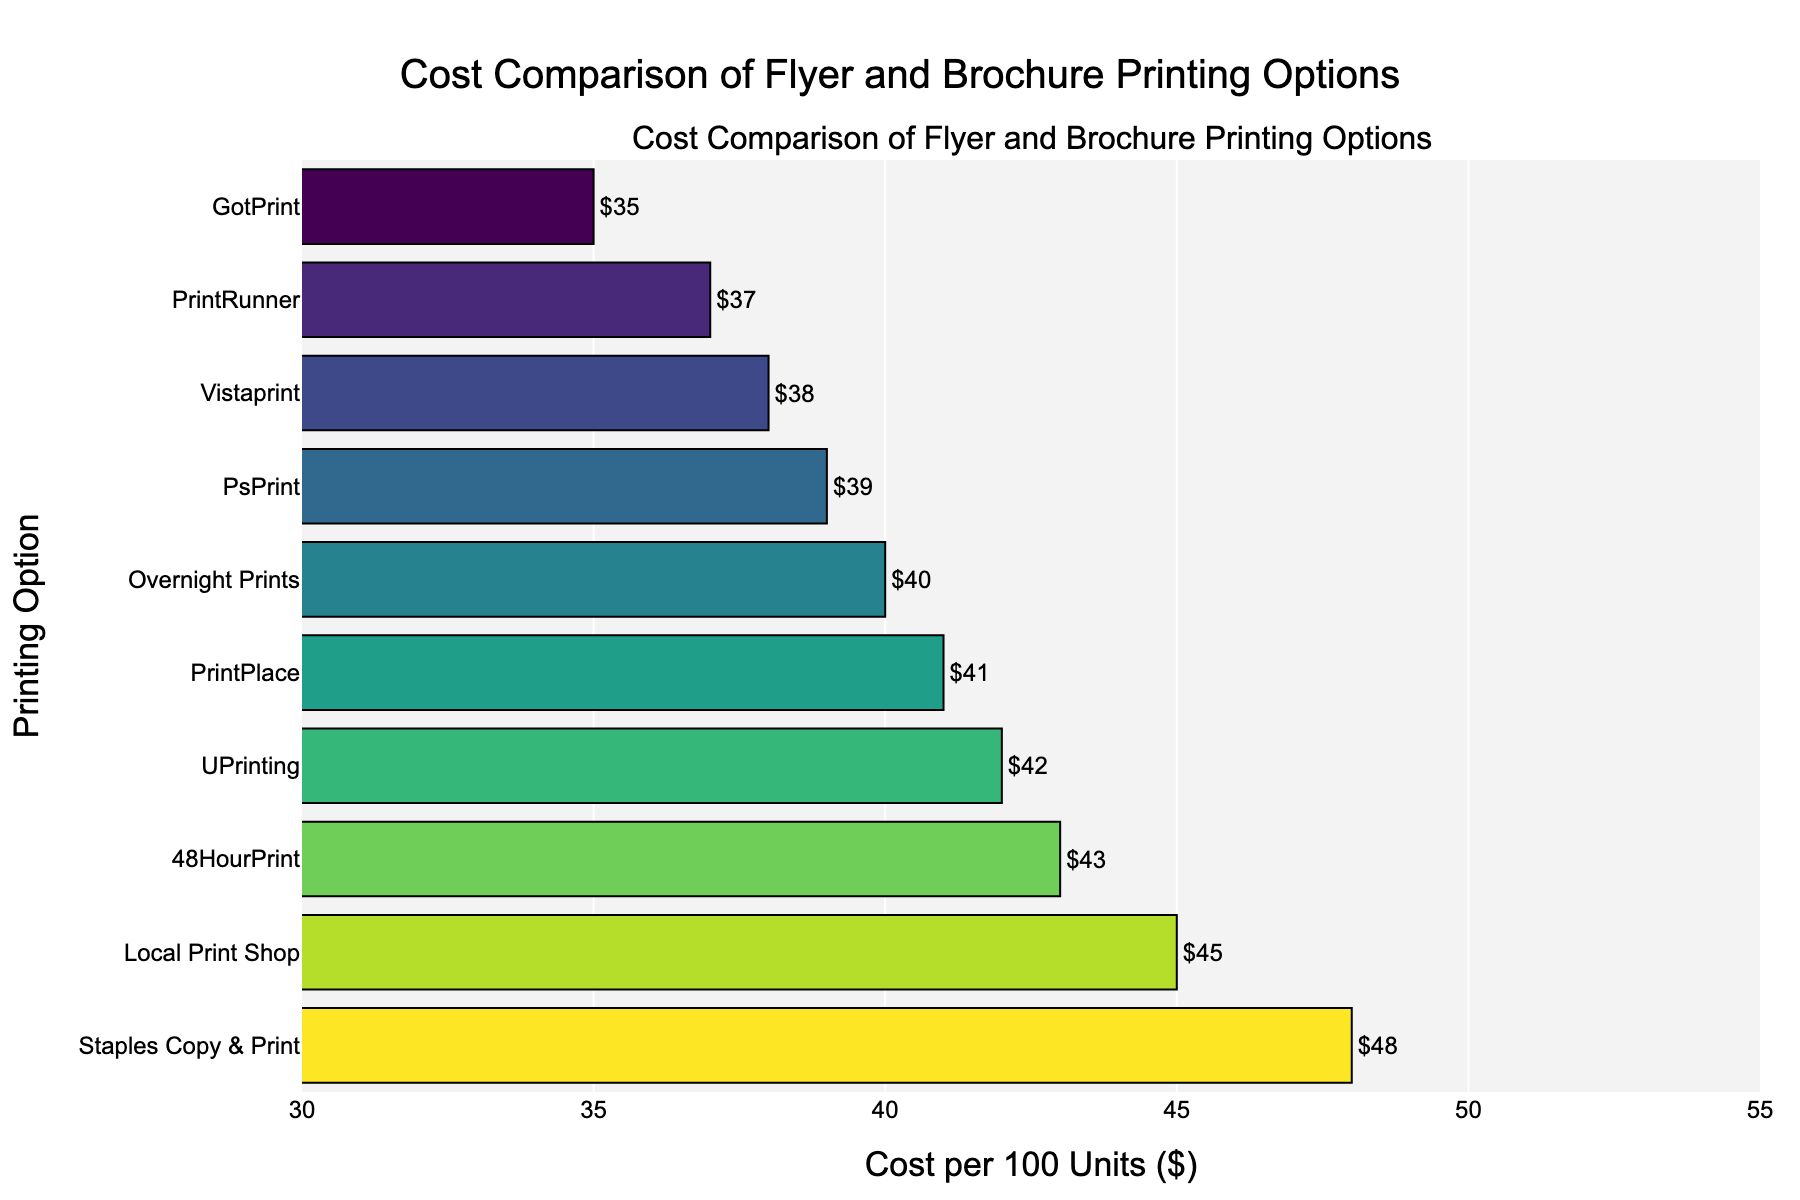What is the cost per 100 units for Vistaprint? Locate Vistaprint in the figure; its bar position indicates the cost.
Answer: $38 Which printing option has the lowest cost per 100 units? Identify the shortest bar; GotPrint has the lowest value.
Answer: GotPrint Compare the costs of Local Print Shop and Staples Copy & Print. Which one is higher? Observe the bar lengths for Local Print Shop and Staples Copy & Print; Staples Copy & Print's bar is longer.
Answer: Staples Copy & Print What is the difference in cost per 100 units between the highest and lowest options? Identify the highest (Staples Copy & Print at $48) and lowest (GotPrint at $35) values. Subtract the lowest from the highest.
Answer: $13 What is the average cost per 100 units for all options? Sum all costs (45 + 38 + 42 + 35 + 40 + 37 + 43 + 39 + 41 + 48 = 408) and divide by the number of options (10).
Answer: $40.8 How many printing options cost less than $40 per 100 units? Count the bars with a cost below $40 (GotPrint, Vistaprint, PrintRunner).
Answer: 3 Which printing option has a cost closest to the average cost per 100 units? Average cost is $40.8. Closest values are PsPrint ($39) and Overnight Prints ($40). Compare differences (40.8-39=1.8 and 40.8-40=0.8). Overnight Prints is closest.
Answer: Overnight Prints Rank the options from highest to lowest cost per 100 units. List sorted by cost: Staples Copy & Print, Local Print Shop, 48HourPrint, PrintPlace, UPrinting, Overnight Prints, PsPrint, PrintRunner, Vistaprint, GotPrint.
Answer: Staples Copy & Print > Local Print Shop > 48HourPrint > PrintPlace > UPrinting > Overnight Prints > PsPrint > PrintRunner > Vistaprint > GotPrint What is the combined cost of the three most expensive printing options? Identify the top three costs (Staples Copy & Print $48, Local Print Shop $45, 48HourPrint $43). Sum these values (48+45+43).
Answer: $136 Which printing option's bar is the longest? Observe the longest bar on the chart; it represents the highest cost.
Answer: Staples Copy & Print 